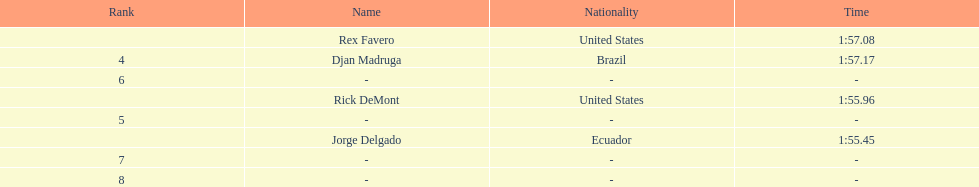Favero finished in 1:57.08. what was the next time? 1:57.17. 